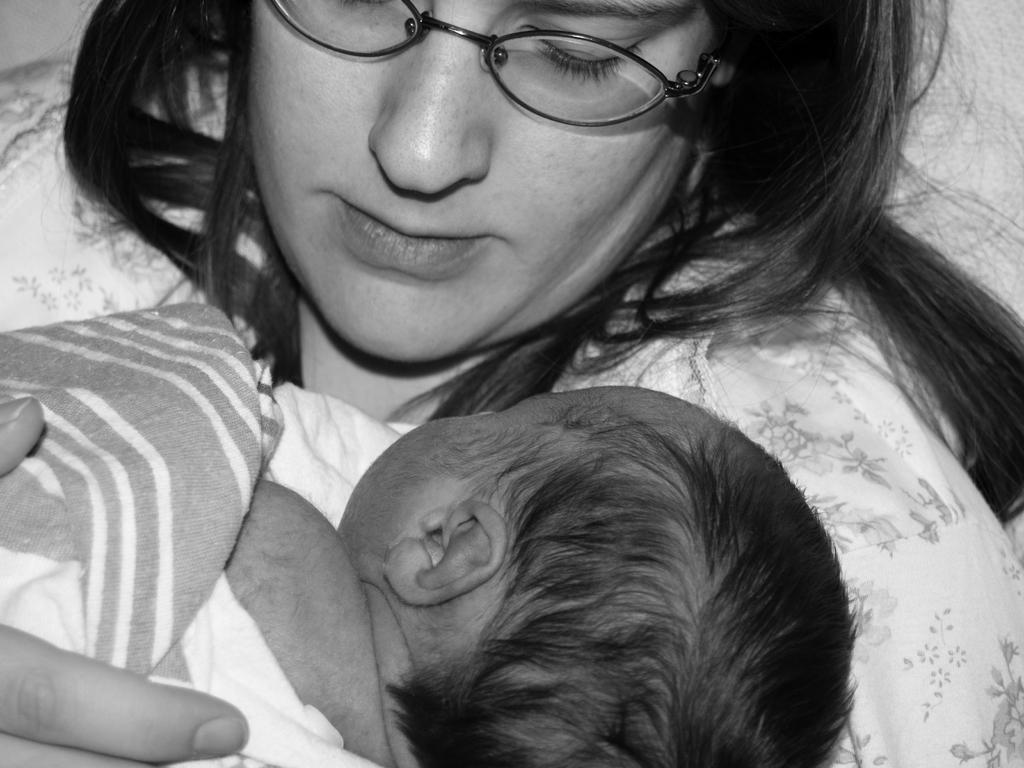What is the person in the image doing? The person is holding a baby in the image. Can you describe the person's appearance? The person is wearing spectacles. What is the color scheme of the image? The image is in black and white. What type of thread is being used to lead the baby in the image? There is no thread or leading action involving the baby in the image; the person is simply holding the baby. Is there a rainstorm occurring in the image? There is no indication of a rainstorm in the image, as it is in black and white and focuses on the person holding the baby. 